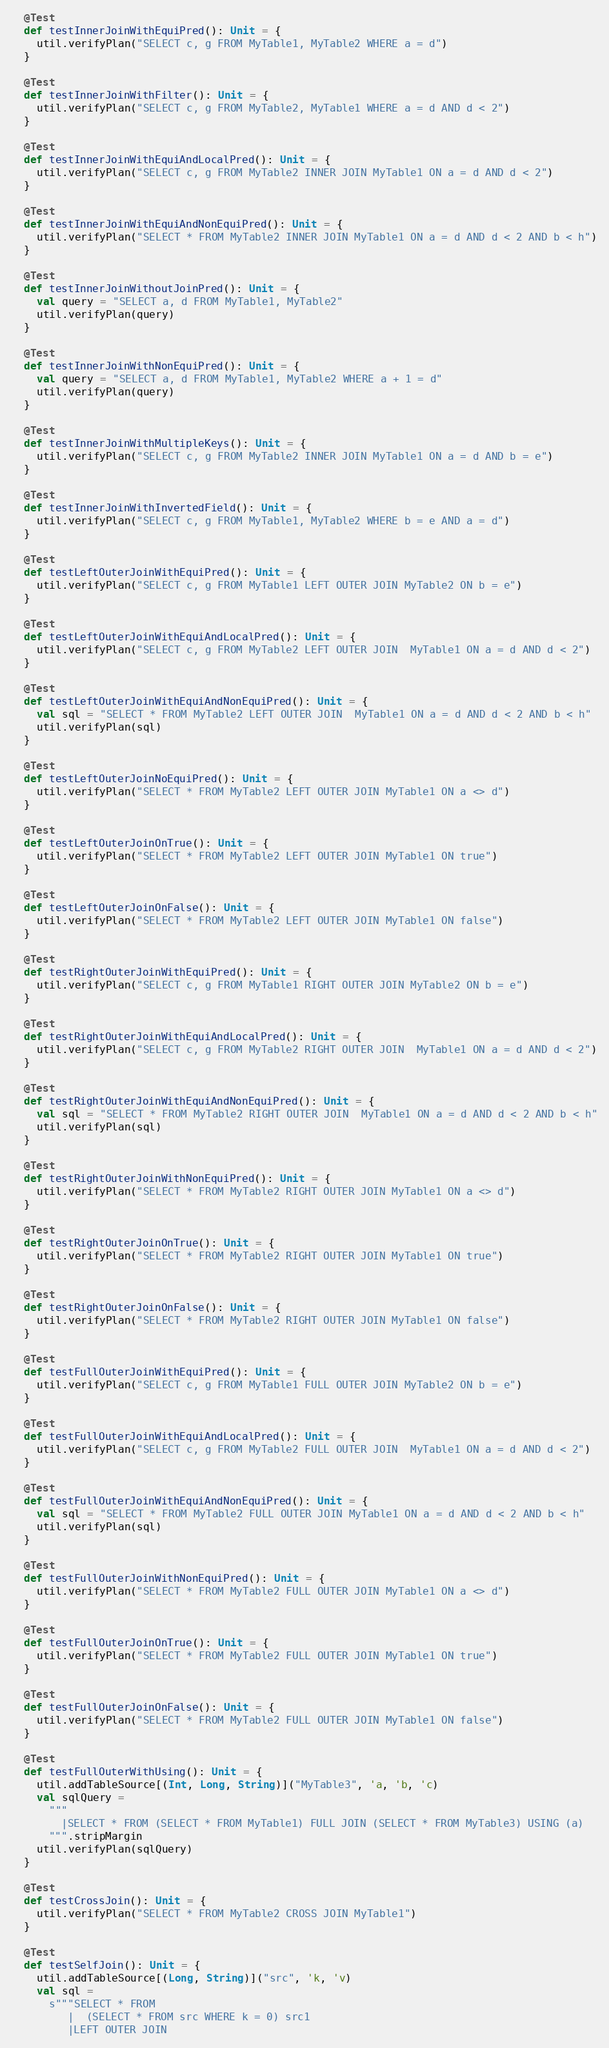<code> <loc_0><loc_0><loc_500><loc_500><_Scala_>  @Test
  def testInnerJoinWithEquiPred(): Unit = {
    util.verifyPlan("SELECT c, g FROM MyTable1, MyTable2 WHERE a = d")
  }

  @Test
  def testInnerJoinWithFilter(): Unit = {
    util.verifyPlan("SELECT c, g FROM MyTable2, MyTable1 WHERE a = d AND d < 2")
  }

  @Test
  def testInnerJoinWithEquiAndLocalPred(): Unit = {
    util.verifyPlan("SELECT c, g FROM MyTable2 INNER JOIN MyTable1 ON a = d AND d < 2")
  }

  @Test
  def testInnerJoinWithEquiAndNonEquiPred(): Unit = {
    util.verifyPlan("SELECT * FROM MyTable2 INNER JOIN MyTable1 ON a = d AND d < 2 AND b < h")
  }

  @Test
  def testInnerJoinWithoutJoinPred(): Unit = {
    val query = "SELECT a, d FROM MyTable1, MyTable2"
    util.verifyPlan(query)
  }

  @Test
  def testInnerJoinWithNonEquiPred(): Unit = {
    val query = "SELECT a, d FROM MyTable1, MyTable2 WHERE a + 1 = d"
    util.verifyPlan(query)
  }

  @Test
  def testInnerJoinWithMultipleKeys(): Unit = {
    util.verifyPlan("SELECT c, g FROM MyTable2 INNER JOIN MyTable1 ON a = d AND b = e")
  }

  @Test
  def testInnerJoinWithInvertedField(): Unit = {
    util.verifyPlan("SELECT c, g FROM MyTable1, MyTable2 WHERE b = e AND a = d")
  }

  @Test
  def testLeftOuterJoinWithEquiPred(): Unit = {
    util.verifyPlan("SELECT c, g FROM MyTable1 LEFT OUTER JOIN MyTable2 ON b = e")
  }

  @Test
  def testLeftOuterJoinWithEquiAndLocalPred(): Unit = {
    util.verifyPlan("SELECT c, g FROM MyTable2 LEFT OUTER JOIN  MyTable1 ON a = d AND d < 2")
  }

  @Test
  def testLeftOuterJoinWithEquiAndNonEquiPred(): Unit = {
    val sql = "SELECT * FROM MyTable2 LEFT OUTER JOIN  MyTable1 ON a = d AND d < 2 AND b < h"
    util.verifyPlan(sql)
  }

  @Test
  def testLeftOuterJoinNoEquiPred(): Unit = {
    util.verifyPlan("SELECT * FROM MyTable2 LEFT OUTER JOIN MyTable1 ON a <> d")
  }

  @Test
  def testLeftOuterJoinOnTrue(): Unit = {
    util.verifyPlan("SELECT * FROM MyTable2 LEFT OUTER JOIN MyTable1 ON true")
  }

  @Test
  def testLeftOuterJoinOnFalse(): Unit = {
    util.verifyPlan("SELECT * FROM MyTable2 LEFT OUTER JOIN MyTable1 ON false")
  }

  @Test
  def testRightOuterJoinWithEquiPred(): Unit = {
    util.verifyPlan("SELECT c, g FROM MyTable1 RIGHT OUTER JOIN MyTable2 ON b = e")
  }

  @Test
  def testRightOuterJoinWithEquiAndLocalPred(): Unit = {
    util.verifyPlan("SELECT c, g FROM MyTable2 RIGHT OUTER JOIN  MyTable1 ON a = d AND d < 2")
  }

  @Test
  def testRightOuterJoinWithEquiAndNonEquiPred(): Unit = {
    val sql = "SELECT * FROM MyTable2 RIGHT OUTER JOIN  MyTable1 ON a = d AND d < 2 AND b < h"
    util.verifyPlan(sql)
  }

  @Test
  def testRightOuterJoinWithNonEquiPred(): Unit = {
    util.verifyPlan("SELECT * FROM MyTable2 RIGHT OUTER JOIN MyTable1 ON a <> d")
  }

  @Test
  def testRightOuterJoinOnTrue(): Unit = {
    util.verifyPlan("SELECT * FROM MyTable2 RIGHT OUTER JOIN MyTable1 ON true")
  }

  @Test
  def testRightOuterJoinOnFalse(): Unit = {
    util.verifyPlan("SELECT * FROM MyTable2 RIGHT OUTER JOIN MyTable1 ON false")
  }

  @Test
  def testFullOuterJoinWithEquiPred(): Unit = {
    util.verifyPlan("SELECT c, g FROM MyTable1 FULL OUTER JOIN MyTable2 ON b = e")
  }

  @Test
  def testFullOuterJoinWithEquiAndLocalPred(): Unit = {
    util.verifyPlan("SELECT c, g FROM MyTable2 FULL OUTER JOIN  MyTable1 ON a = d AND d < 2")
  }

  @Test
  def testFullOuterJoinWithEquiAndNonEquiPred(): Unit = {
    val sql = "SELECT * FROM MyTable2 FULL OUTER JOIN MyTable1 ON a = d AND d < 2 AND b < h"
    util.verifyPlan(sql)
  }

  @Test
  def testFullOuterJoinWithNonEquiPred(): Unit = {
    util.verifyPlan("SELECT * FROM MyTable2 FULL OUTER JOIN MyTable1 ON a <> d")
  }

  @Test
  def testFullOuterJoinOnTrue(): Unit = {
    util.verifyPlan("SELECT * FROM MyTable2 FULL OUTER JOIN MyTable1 ON true")
  }

  @Test
  def testFullOuterJoinOnFalse(): Unit = {
    util.verifyPlan("SELECT * FROM MyTable2 FULL OUTER JOIN MyTable1 ON false")
  }

  @Test
  def testFullOuterWithUsing(): Unit = {
    util.addTableSource[(Int, Long, String)]("MyTable3", 'a, 'b, 'c)
    val sqlQuery =
      """
        |SELECT * FROM (SELECT * FROM MyTable1) FULL JOIN (SELECT * FROM MyTable3) USING (a)
      """.stripMargin
    util.verifyPlan(sqlQuery)
  }

  @Test
  def testCrossJoin(): Unit = {
    util.verifyPlan("SELECT * FROM MyTable2 CROSS JOIN MyTable1")
  }

  @Test
  def testSelfJoin(): Unit = {
    util.addTableSource[(Long, String)]("src", 'k, 'v)
    val sql =
      s"""SELECT * FROM
         |  (SELECT * FROM src WHERE k = 0) src1
         |LEFT OUTER JOIN</code> 